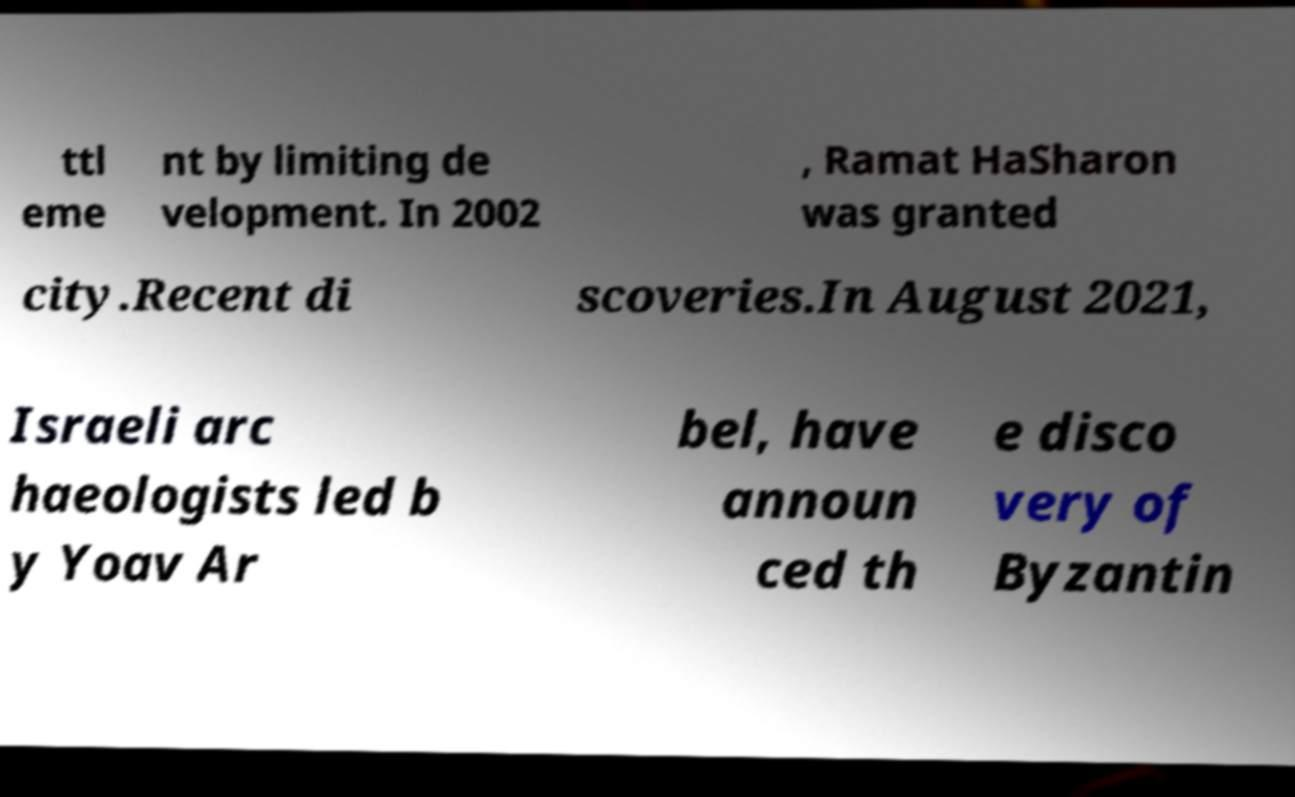Can you read and provide the text displayed in the image?This photo seems to have some interesting text. Can you extract and type it out for me? ttl eme nt by limiting de velopment. In 2002 , Ramat HaSharon was granted city.Recent di scoveries.In August 2021, Israeli arc haeologists led b y Yoav Ar bel, have announ ced th e disco very of Byzantin 